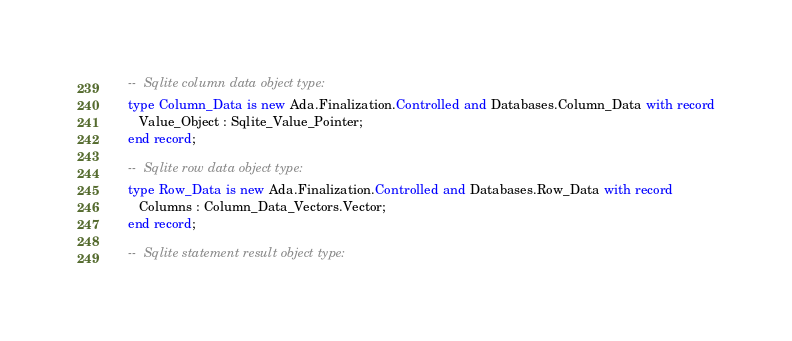<code> <loc_0><loc_0><loc_500><loc_500><_Ada_>
   --  Sqlite column data object type:
   type Column_Data is new Ada.Finalization.Controlled and Databases.Column_Data with record
      Value_Object : Sqlite_Value_Pointer;
   end record;

   --  Sqlite row data object type:
   type Row_Data is new Ada.Finalization.Controlled and Databases.Row_Data with record
      Columns : Column_Data_Vectors.Vector;
   end record;

   --  Sqlite statement result object type:</code> 